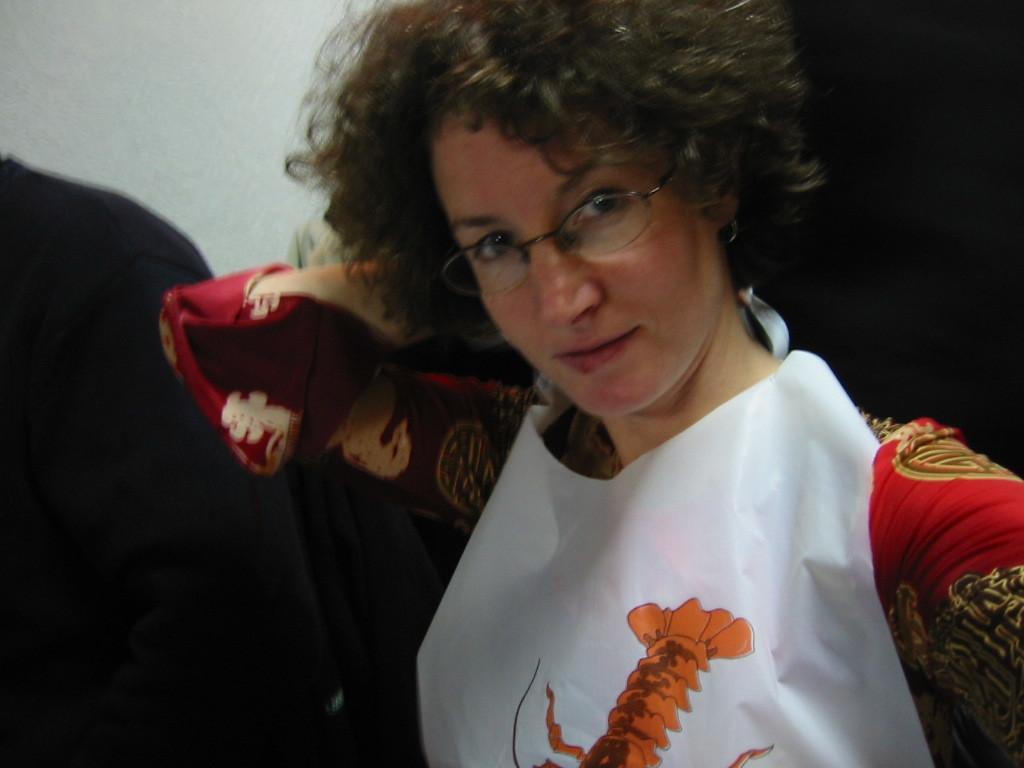In one or two sentences, can you explain what this image depicts? In this picture a lady who is dressed in red is wearing a white designed apron , also she is wearing a spectacles and she has a curly hair. 